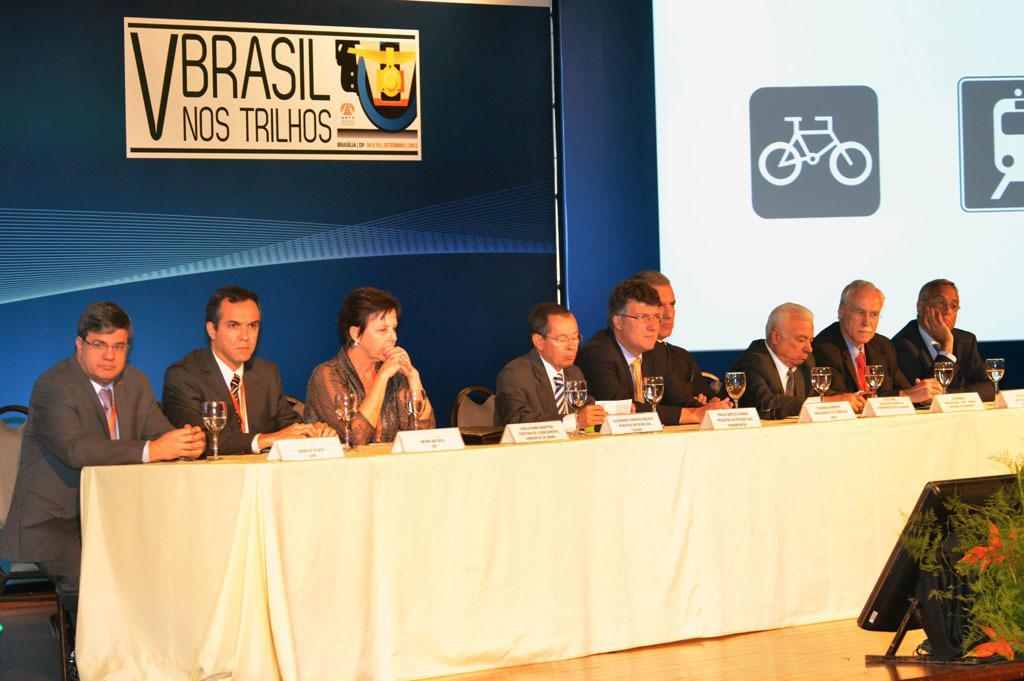In one or two sentences, can you explain what this image depicts? There are glasses and name boards are present on a table which is covered with white color cloth as we can see at the bottom of this image. There are people sitting on the chairs in the middle of this image and there is a wall in the background. We can see logos at the top of this image. 